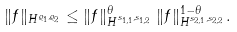<formula> <loc_0><loc_0><loc_500><loc_500>\| f \| _ { H ^ { \varrho _ { 1 } , \varrho _ { 2 } } } \leq \| f \| _ { H ^ { s _ { 1 , 1 } , s _ { 1 , 2 } } } ^ { \theta } \, \| f \| _ { H ^ { s _ { 2 , 1 } , s _ { 2 , 2 } } } ^ { 1 - \theta } .</formula> 